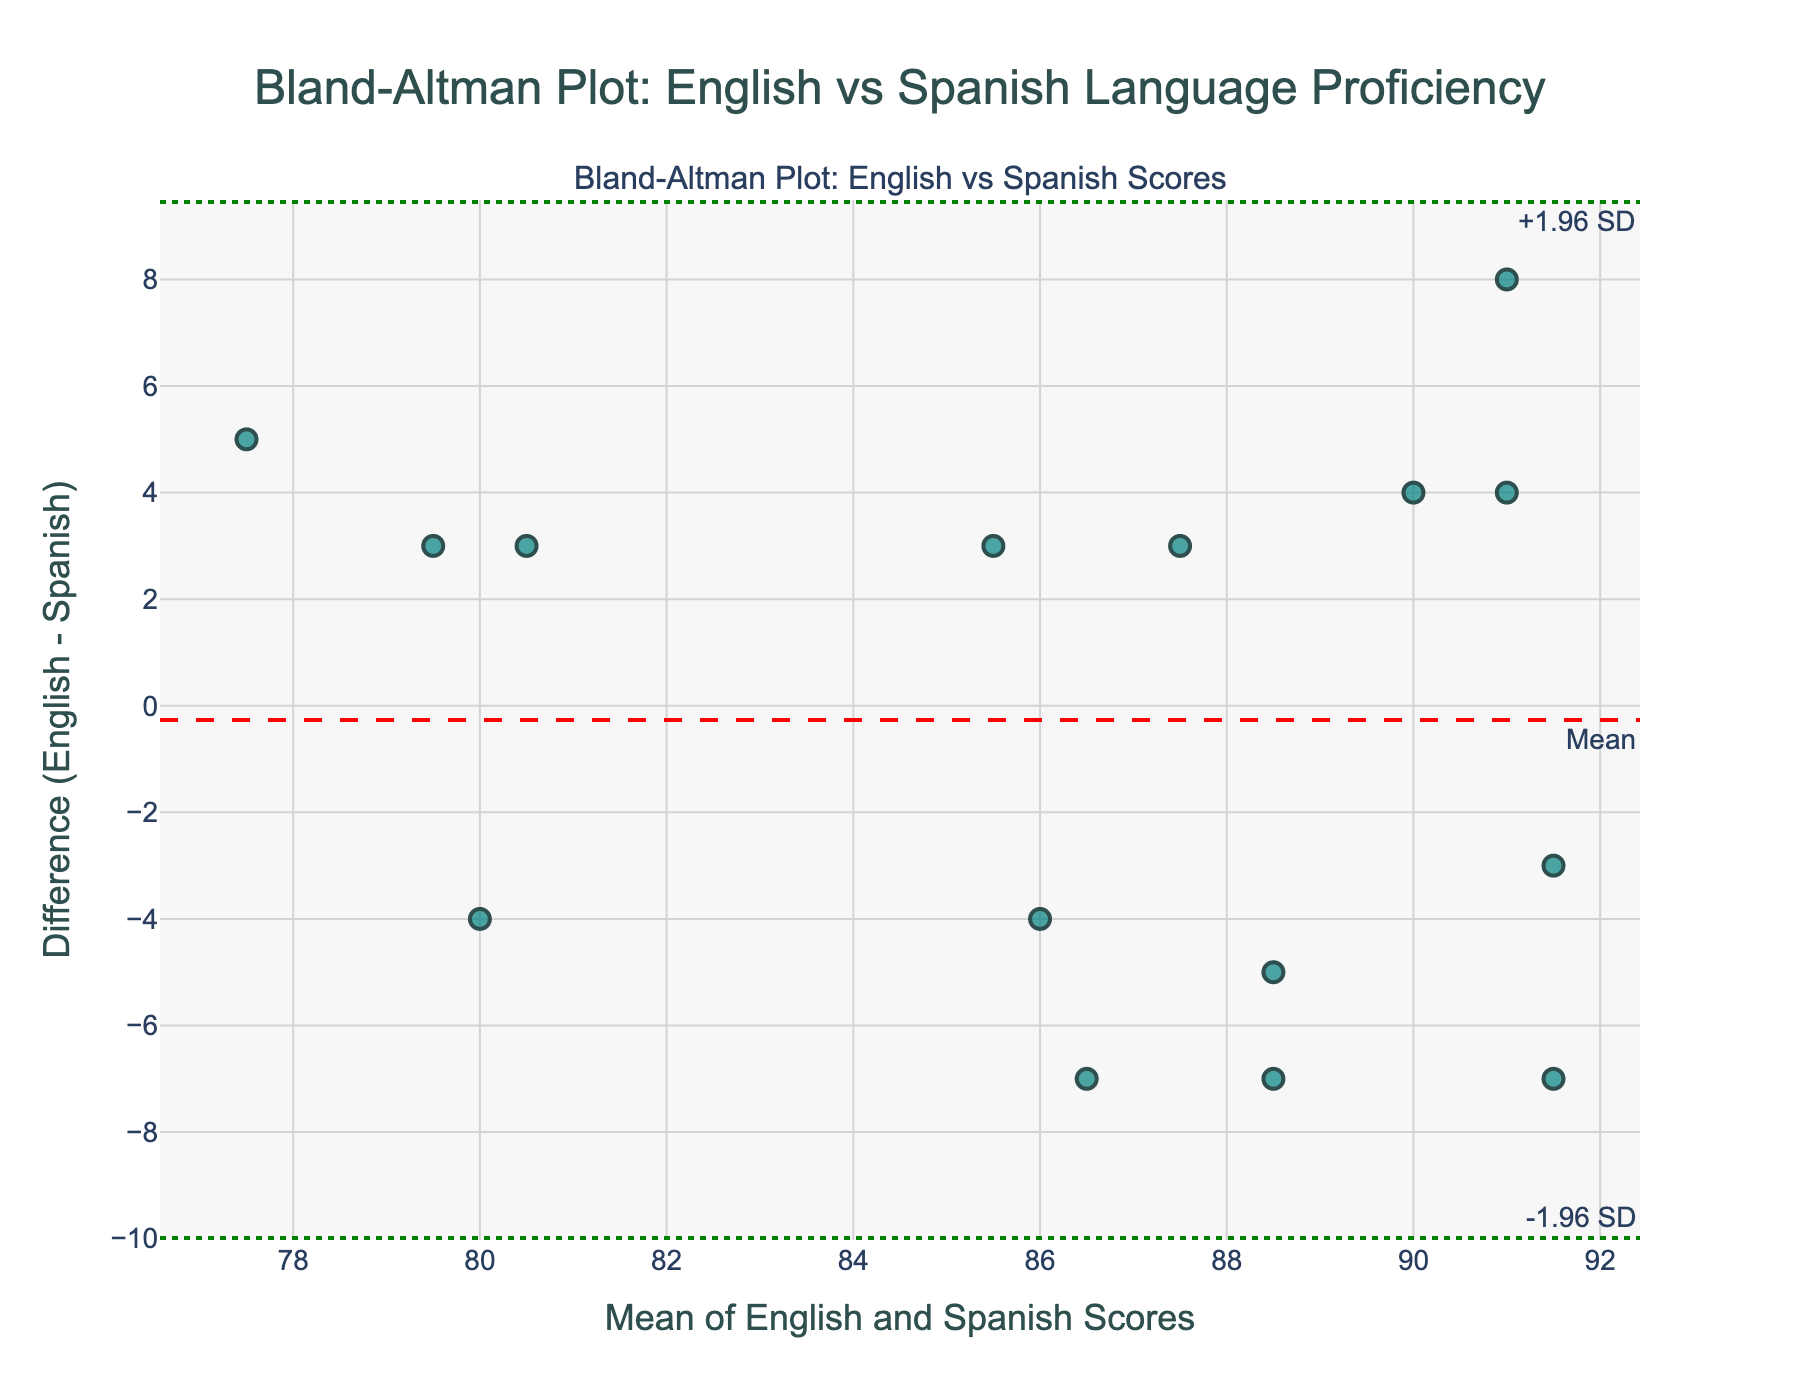What is the title of the plot? The title of the plot is usually located at the top and is indicated in a larger and bolder font compared to other texts.
Answer: Bland-Altman Plot: English vs Spanish Language Proficiency How many data points are present in the plot? We count the number of markers shown in the scatter plot. Each marker represents a data point.
Answer: 15 What color are the markers for the data points? The color of the markers is readily visible in the figure.
Answer: Teal What do the horizontal dashed and dotted lines represent? The horizontal dashed line that corresponds to the average difference between scores is typically red and labelled "Mean". The two horizontal dotted lines usually indicate the limits of agreement (mean difference ± 1.96 times the standard deviation) and are green.
Answer: The red dashed line represents the mean difference, and the green dotted lines represent ±1.96 SD limits of agreement What is the value of the mean difference line? The mean difference line value can be seen on the y-axis where the red dashed line intersects.
Answer: Approximately 1.1 Which student has the highest mean score? By hovering over data points, we can view the details, including the student names and their mean scores. The student with the highest mean score would have the highest x-axis value.
Answer: Carlos Gomez What is the range of the differences (English - Spanish) recorded in the plot? To determine the range, find the highest and lowest y-values (differences) and subtract the lowest y-value from the highest.
Answer: -5 to 7 How many students have a higher score in Spanish than in English? By checking the markers below the y=0 line (i.e., negative differences), count these data points.
Answer: 6 What is the lower limit of agreement (LoA) value? The lower limit of agreement is represented by a green dotted line, and its y-value can be noted where this line intersects the y-axis.
Answer: Approximately -4.5 Is the majority of the data within the limits of agreement? To determine this, observe the number of data points within the two green dotted lines. If most markers are between these lines, then the majority are within the limits of agreement.
Answer: Yes 